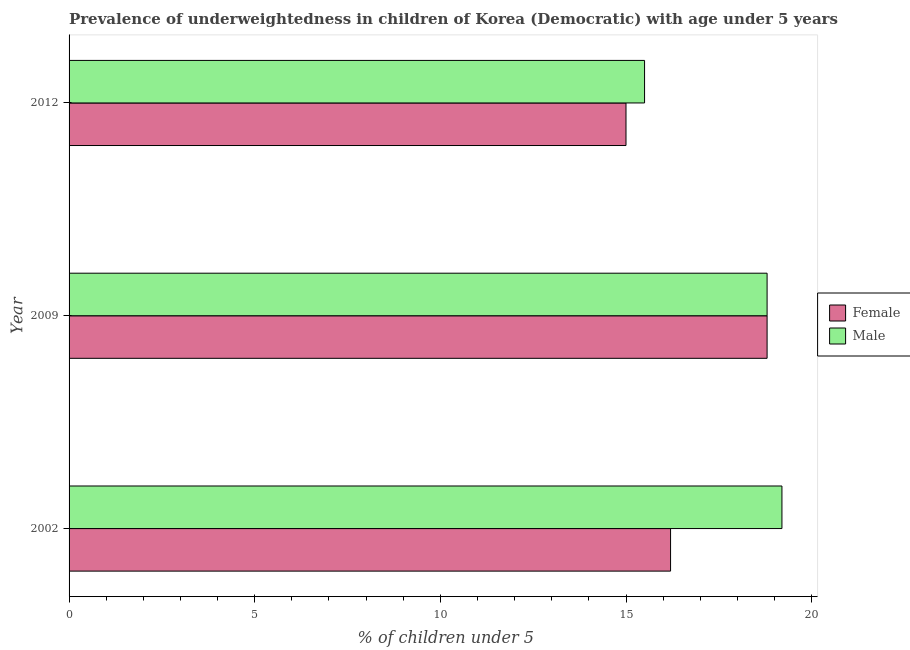How many different coloured bars are there?
Your answer should be compact. 2. Are the number of bars per tick equal to the number of legend labels?
Your response must be concise. Yes. Are the number of bars on each tick of the Y-axis equal?
Offer a terse response. Yes. How many bars are there on the 1st tick from the top?
Keep it short and to the point. 2. What is the label of the 1st group of bars from the top?
Offer a very short reply. 2012. What is the percentage of underweighted female children in 2009?
Provide a short and direct response. 18.8. Across all years, what is the maximum percentage of underweighted female children?
Keep it short and to the point. 18.8. Across all years, what is the minimum percentage of underweighted male children?
Your response must be concise. 15.5. What is the total percentage of underweighted male children in the graph?
Provide a short and direct response. 53.5. What is the difference between the percentage of underweighted female children in 2009 and that in 2012?
Provide a succinct answer. 3.8. What is the difference between the percentage of underweighted male children in 2002 and the percentage of underweighted female children in 2012?
Provide a succinct answer. 4.2. What is the average percentage of underweighted female children per year?
Make the answer very short. 16.67. What is the ratio of the percentage of underweighted female children in 2002 to that in 2009?
Your response must be concise. 0.86. Is the percentage of underweighted male children in 2002 less than that in 2009?
Provide a short and direct response. No. What is the difference between the highest and the lowest percentage of underweighted female children?
Ensure brevity in your answer.  3.8. In how many years, is the percentage of underweighted male children greater than the average percentage of underweighted male children taken over all years?
Offer a terse response. 2. What does the 1st bar from the top in 2002 represents?
Your response must be concise. Male. How many bars are there?
Provide a succinct answer. 6. How many years are there in the graph?
Your answer should be very brief. 3. What is the difference between two consecutive major ticks on the X-axis?
Make the answer very short. 5. Does the graph contain grids?
Provide a short and direct response. No. How are the legend labels stacked?
Offer a terse response. Vertical. What is the title of the graph?
Offer a very short reply. Prevalence of underweightedness in children of Korea (Democratic) with age under 5 years. Does "Female labourers" appear as one of the legend labels in the graph?
Offer a very short reply. No. What is the label or title of the X-axis?
Keep it short and to the point.  % of children under 5. What is the label or title of the Y-axis?
Your answer should be compact. Year. What is the  % of children under 5 in Female in 2002?
Give a very brief answer. 16.2. What is the  % of children under 5 of Male in 2002?
Keep it short and to the point. 19.2. What is the  % of children under 5 of Female in 2009?
Provide a succinct answer. 18.8. What is the  % of children under 5 in Male in 2009?
Your response must be concise. 18.8. Across all years, what is the maximum  % of children under 5 in Female?
Offer a terse response. 18.8. Across all years, what is the maximum  % of children under 5 of Male?
Your response must be concise. 19.2. Across all years, what is the minimum  % of children under 5 in Male?
Offer a terse response. 15.5. What is the total  % of children under 5 of Female in the graph?
Your answer should be compact. 50. What is the total  % of children under 5 of Male in the graph?
Give a very brief answer. 53.5. What is the difference between the  % of children under 5 of Male in 2002 and that in 2009?
Keep it short and to the point. 0.4. What is the difference between the  % of children under 5 of Female in 2002 and that in 2012?
Make the answer very short. 1.2. What is the difference between the  % of children under 5 of Female in 2009 and that in 2012?
Your answer should be compact. 3.8. What is the average  % of children under 5 in Female per year?
Offer a very short reply. 16.67. What is the average  % of children under 5 of Male per year?
Offer a very short reply. 17.83. In the year 2002, what is the difference between the  % of children under 5 in Female and  % of children under 5 in Male?
Keep it short and to the point. -3. In the year 2009, what is the difference between the  % of children under 5 in Female and  % of children under 5 in Male?
Offer a very short reply. 0. In the year 2012, what is the difference between the  % of children under 5 in Female and  % of children under 5 in Male?
Give a very brief answer. -0.5. What is the ratio of the  % of children under 5 in Female in 2002 to that in 2009?
Give a very brief answer. 0.86. What is the ratio of the  % of children under 5 of Male in 2002 to that in 2009?
Ensure brevity in your answer.  1.02. What is the ratio of the  % of children under 5 in Male in 2002 to that in 2012?
Keep it short and to the point. 1.24. What is the ratio of the  % of children under 5 of Female in 2009 to that in 2012?
Give a very brief answer. 1.25. What is the ratio of the  % of children under 5 in Male in 2009 to that in 2012?
Offer a terse response. 1.21. What is the difference between the highest and the second highest  % of children under 5 of Male?
Give a very brief answer. 0.4. What is the difference between the highest and the lowest  % of children under 5 of Female?
Your response must be concise. 3.8. What is the difference between the highest and the lowest  % of children under 5 in Male?
Your response must be concise. 3.7. 